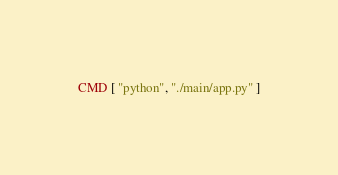<code> <loc_0><loc_0><loc_500><loc_500><_Dockerfile_>
CMD [ "python", "./main/app.py" ]
</code> 